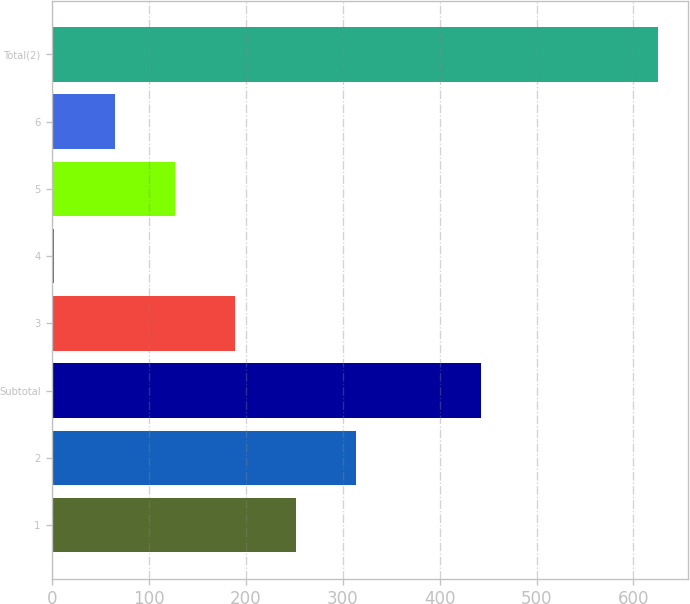Convert chart to OTSL. <chart><loc_0><loc_0><loc_500><loc_500><bar_chart><fcel>1<fcel>2<fcel>Subtotal<fcel>3<fcel>4<fcel>5<fcel>6<fcel>Total(2)<nl><fcel>251.36<fcel>313.64<fcel>443<fcel>189.08<fcel>2.24<fcel>126.8<fcel>64.52<fcel>625<nl></chart> 